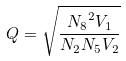<formula> <loc_0><loc_0><loc_500><loc_500>Q = \sqrt { \frac { { N _ { 8 } } ^ { 2 } V _ { 1 } } { N _ { 2 } N _ { 5 } V _ { 2 } } }</formula> 